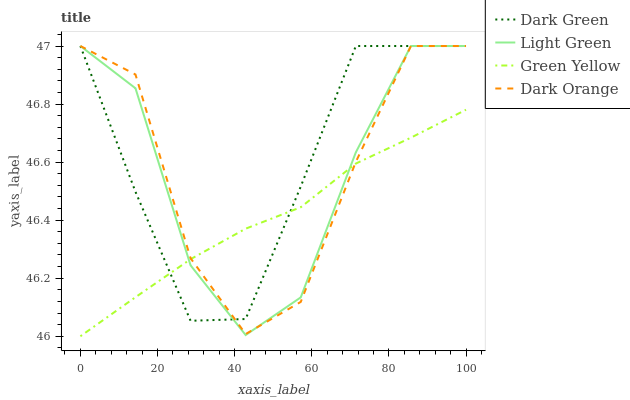Does Green Yellow have the minimum area under the curve?
Answer yes or no. Yes. Does Dark Green have the maximum area under the curve?
Answer yes or no. Yes. Does Light Green have the minimum area under the curve?
Answer yes or no. No. Does Light Green have the maximum area under the curve?
Answer yes or no. No. Is Green Yellow the smoothest?
Answer yes or no. Yes. Is Dark Orange the roughest?
Answer yes or no. Yes. Is Light Green the smoothest?
Answer yes or no. No. Is Light Green the roughest?
Answer yes or no. No. Does Green Yellow have the lowest value?
Answer yes or no. Yes. Does Light Green have the lowest value?
Answer yes or no. No. Does Dark Green have the highest value?
Answer yes or no. Yes. Does Green Yellow have the highest value?
Answer yes or no. No. Does Dark Green intersect Light Green?
Answer yes or no. Yes. Is Dark Green less than Light Green?
Answer yes or no. No. Is Dark Green greater than Light Green?
Answer yes or no. No. 